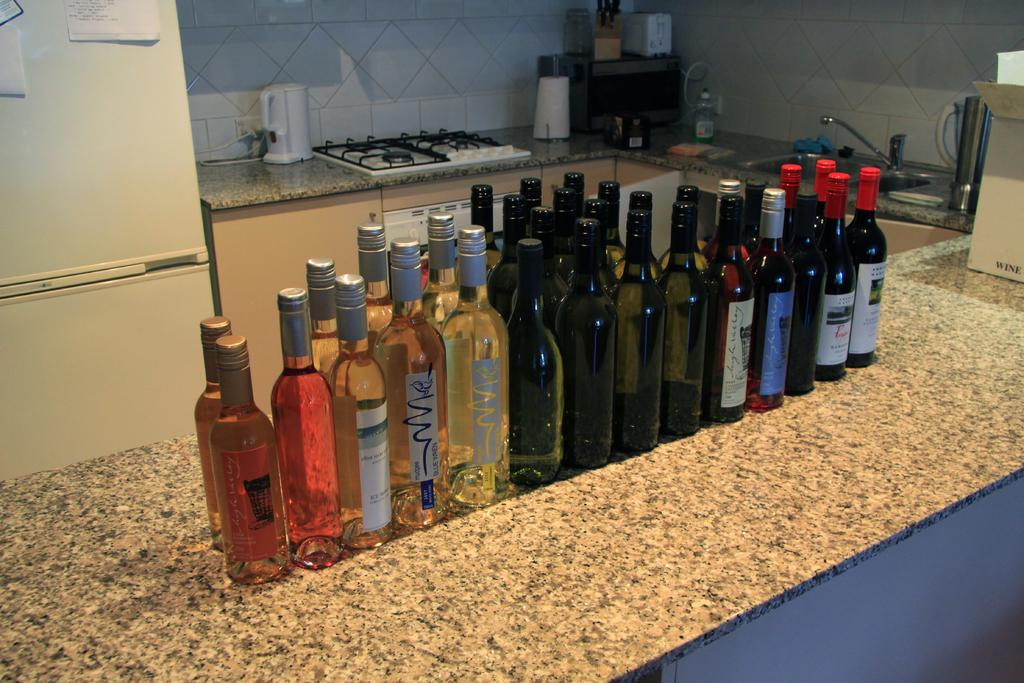What type of beverage containers are visible in the image? There are wine bottles in the image. Where are the wine bottles located? The wine bottles are on a countertop. In which room of the house is the countertop located? The countertop is in a kitchen. What type of stove is present in the kitchen? There is a gas stove in the kitchen. What other appliance is present in the kitchen? There is a refrigerator in the kitchen. What type of government is depicted in the image? There is no depiction of a government in the image; it features wine bottles on a countertop in a kitchen. Can you see a rabbit hopping around in the image? There is no rabbit present in the image. 